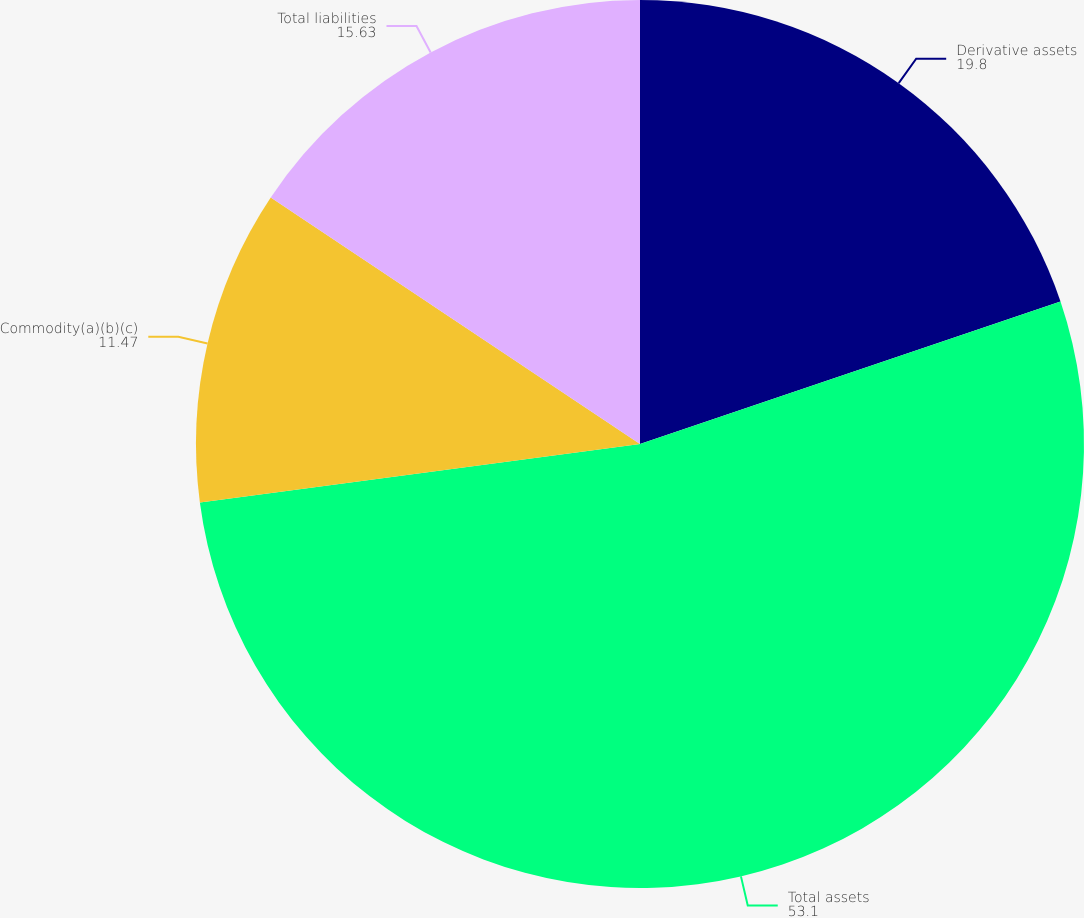<chart> <loc_0><loc_0><loc_500><loc_500><pie_chart><fcel>Derivative assets<fcel>Total assets<fcel>Commodity(a)(b)(c)<fcel>Total liabilities<nl><fcel>19.8%<fcel>53.1%<fcel>11.47%<fcel>15.63%<nl></chart> 